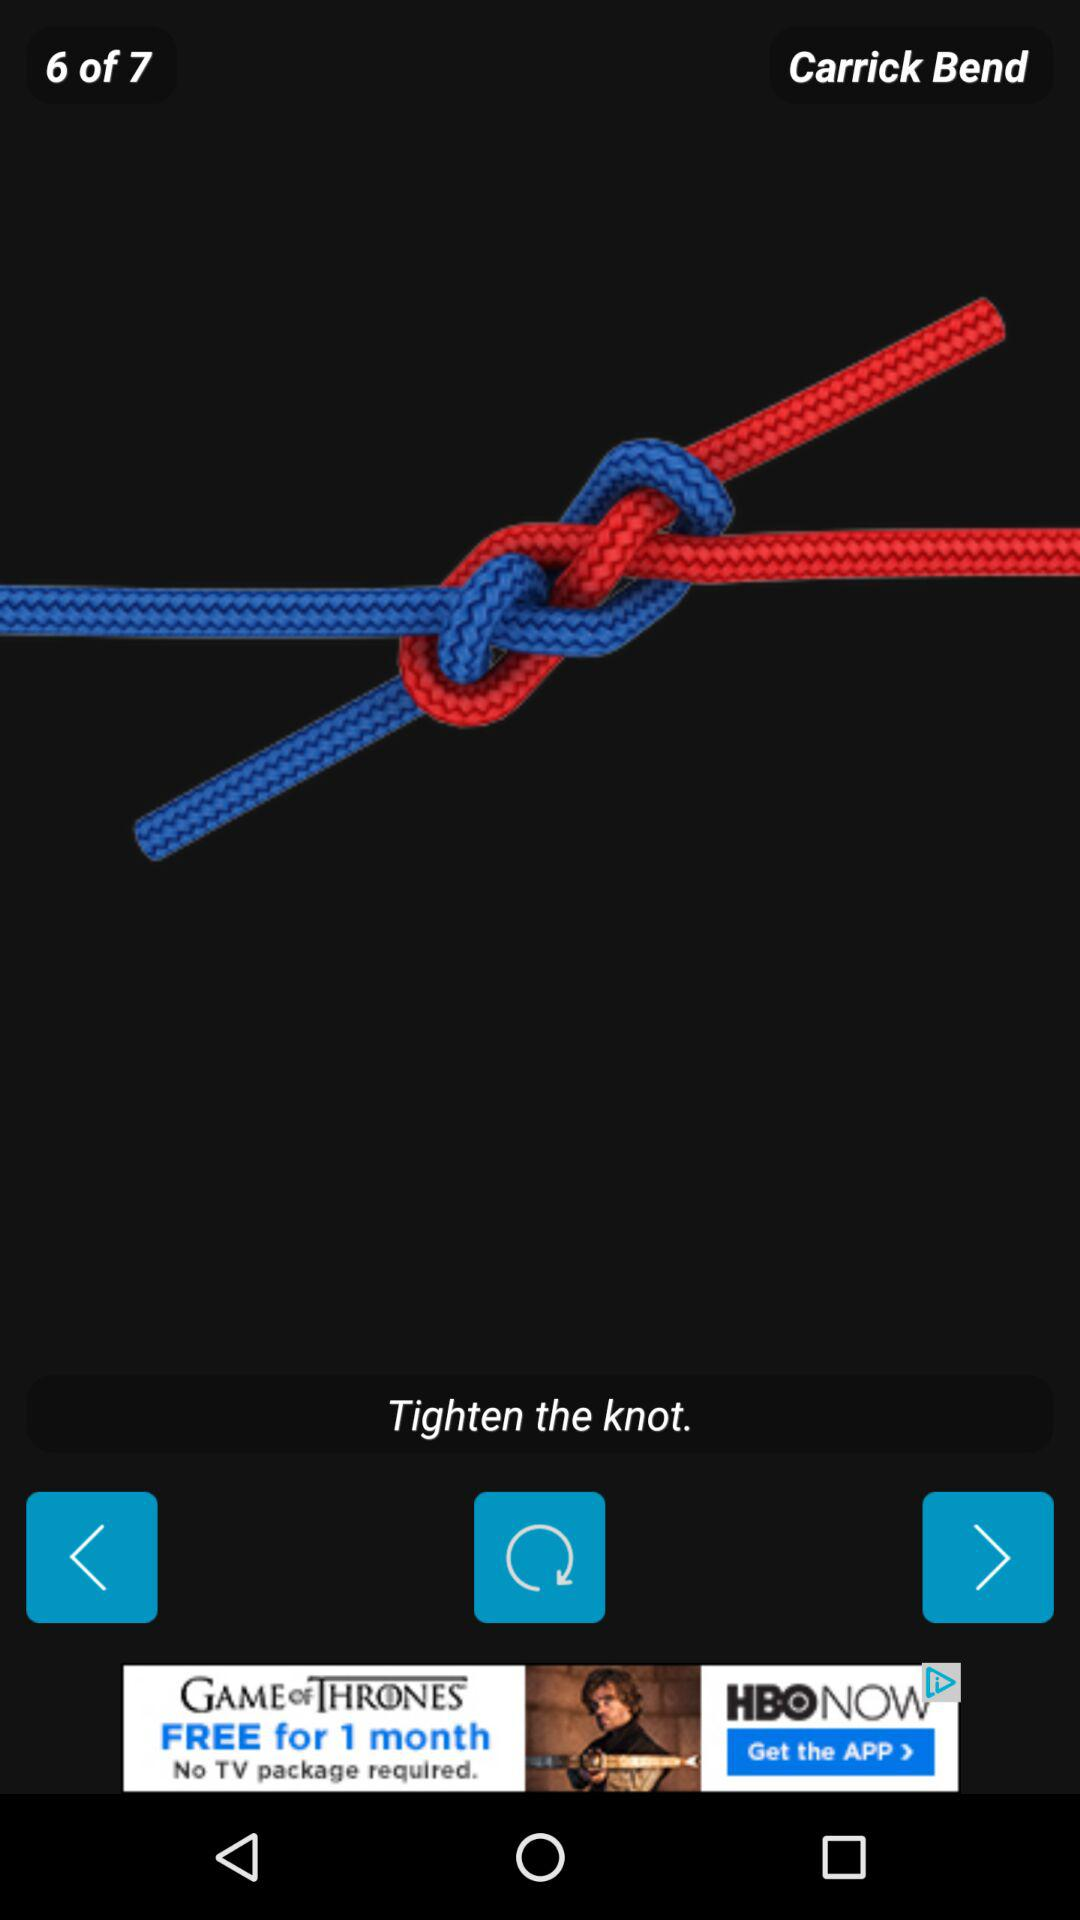How many bends in total are there? There are seven bends. 